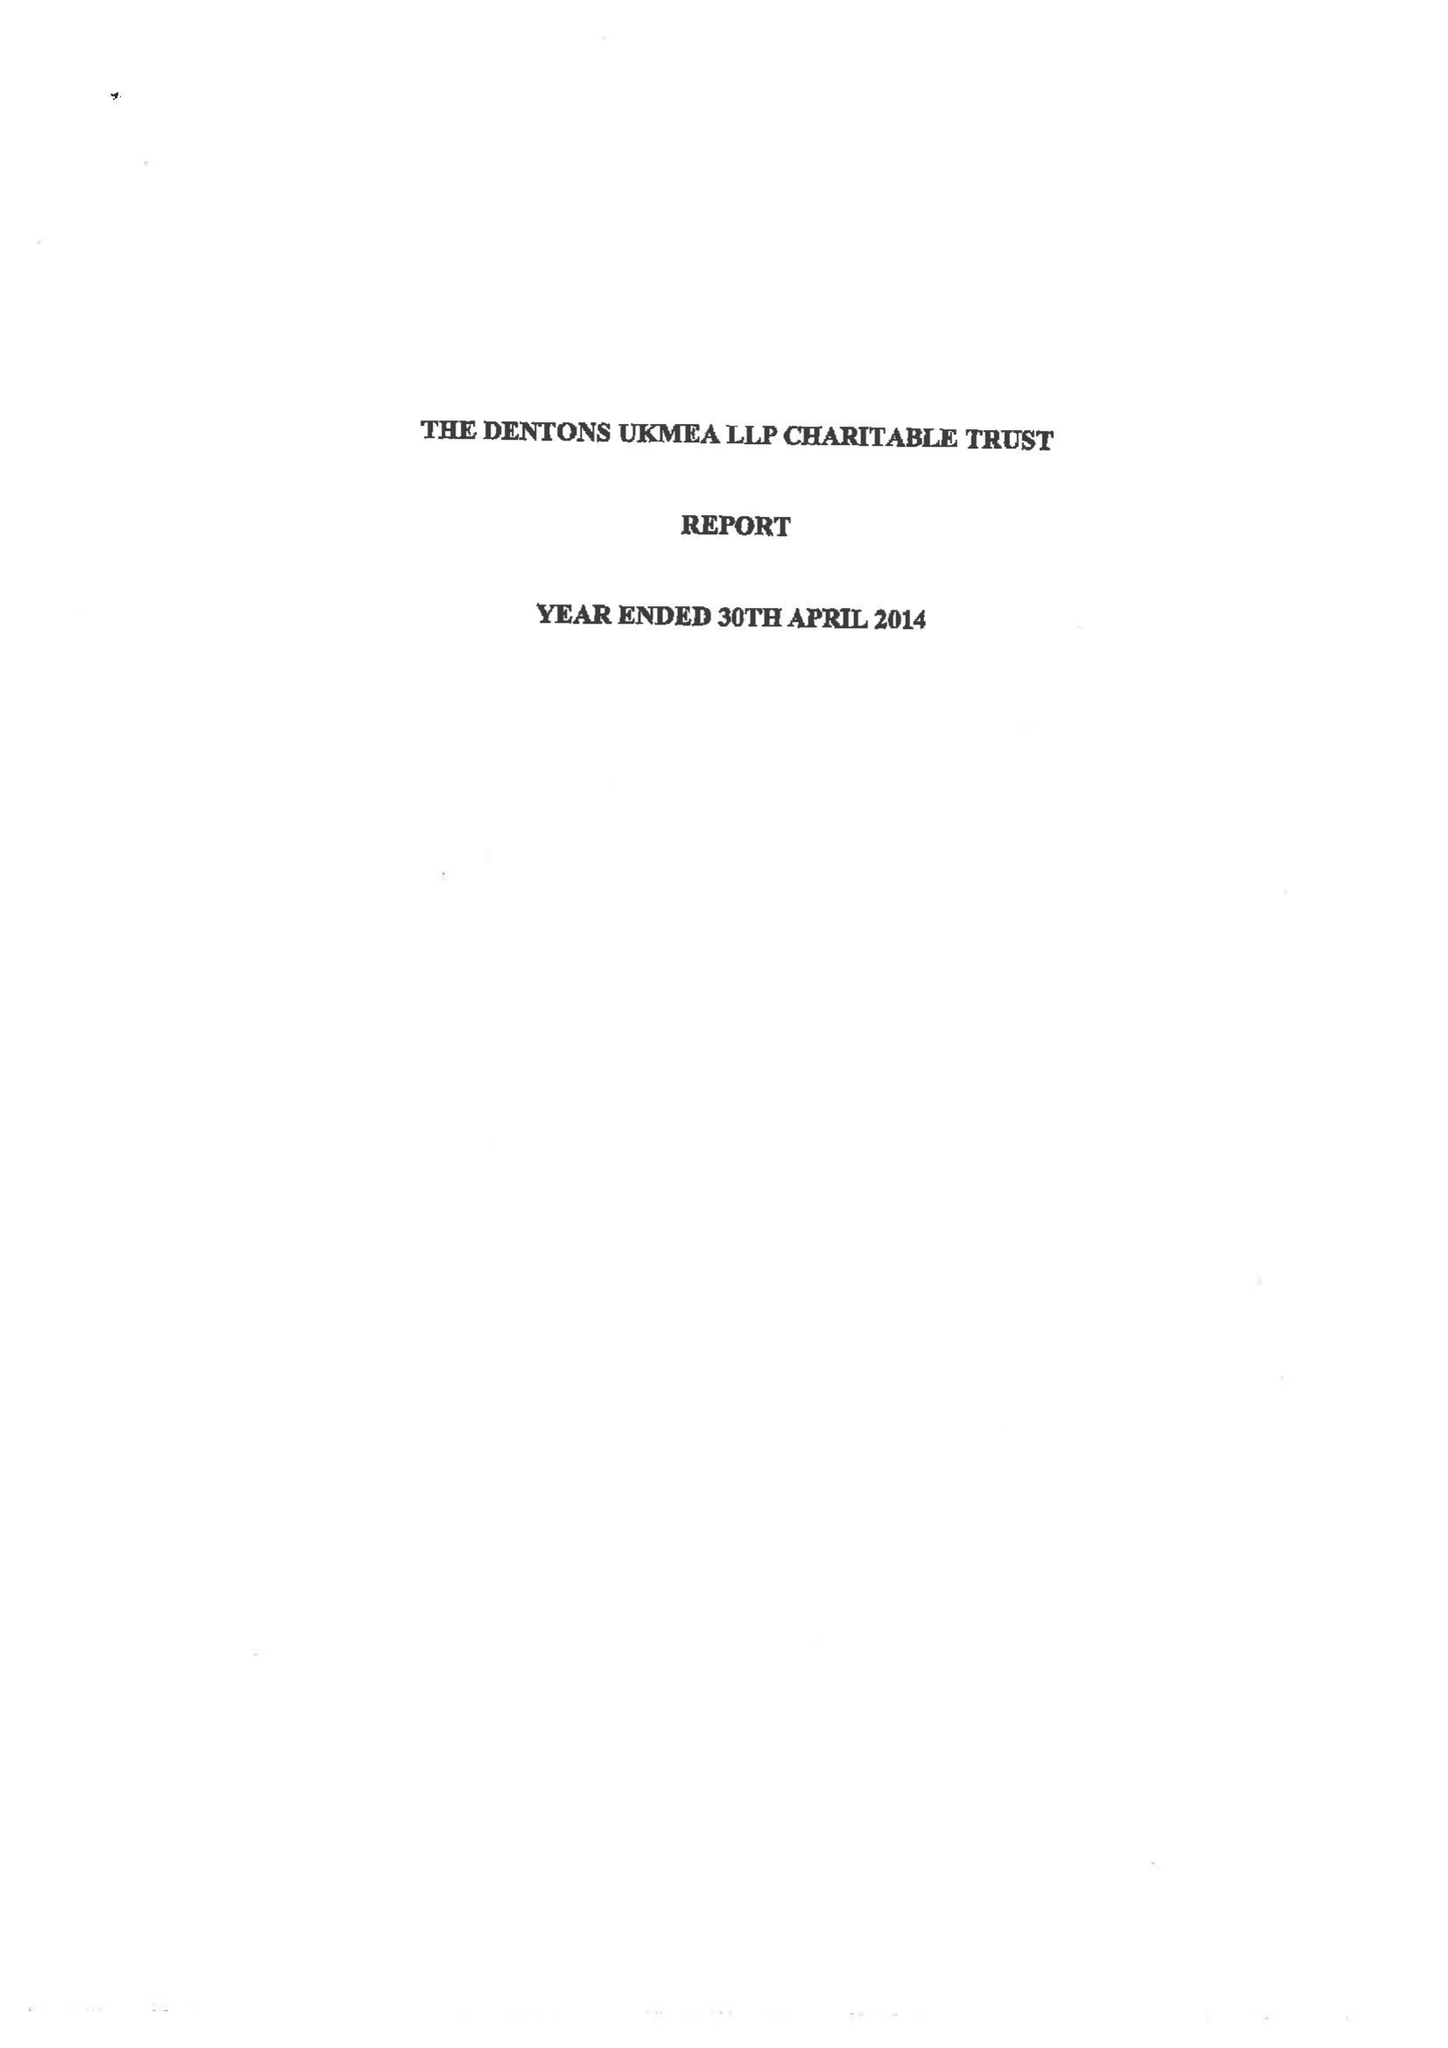What is the value for the charity_number?
Answer the question using a single word or phrase. 1041204 